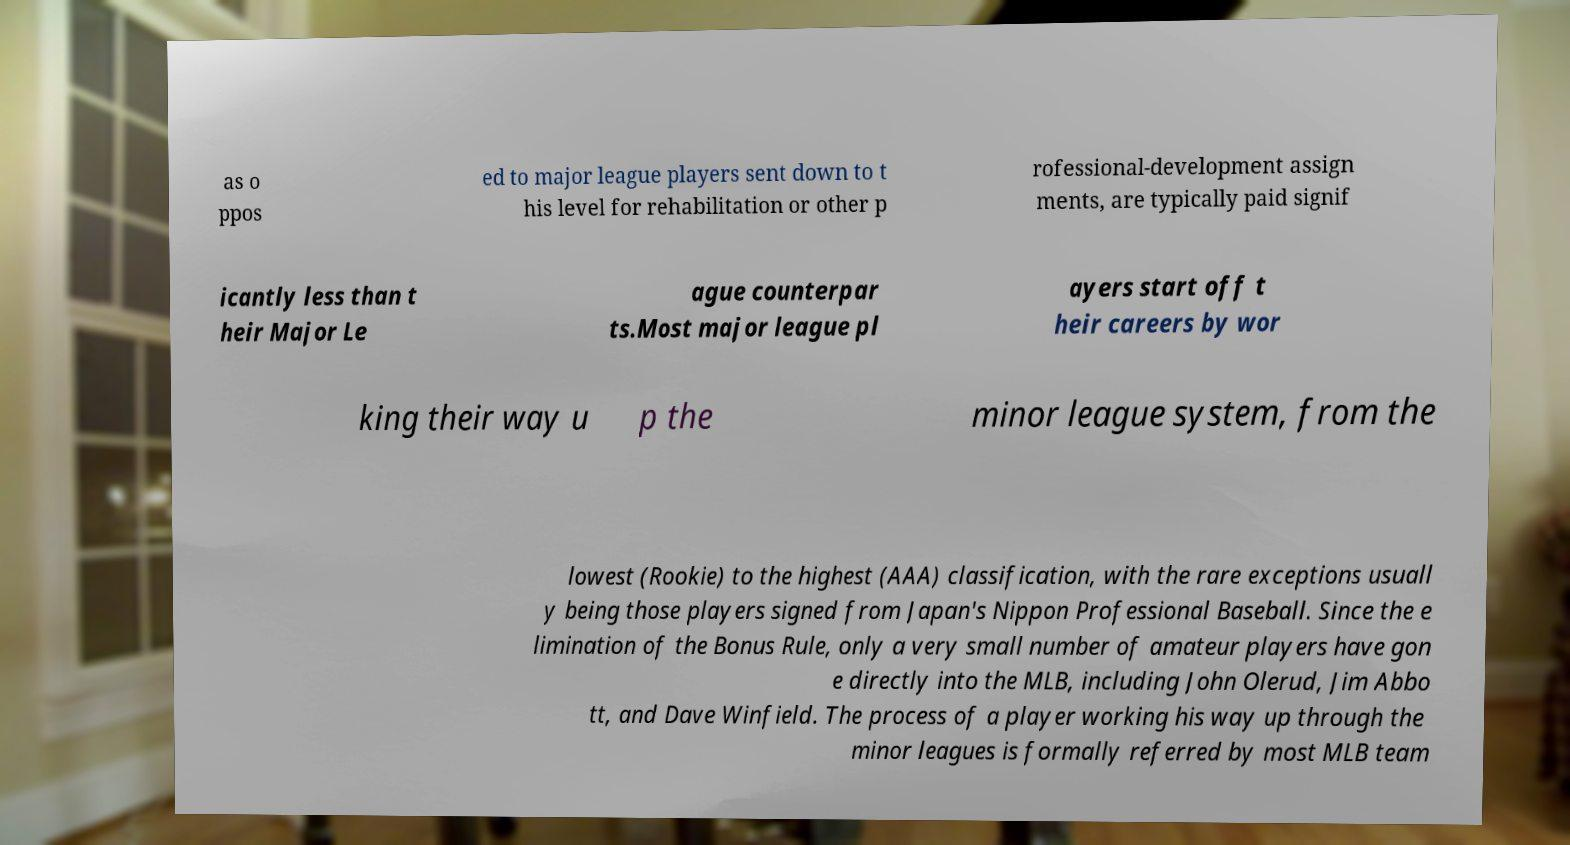Could you assist in decoding the text presented in this image and type it out clearly? as o ppos ed to major league players sent down to t his level for rehabilitation or other p rofessional-development assign ments, are typically paid signif icantly less than t heir Major Le ague counterpar ts.Most major league pl ayers start off t heir careers by wor king their way u p the minor league system, from the lowest (Rookie) to the highest (AAA) classification, with the rare exceptions usuall y being those players signed from Japan's Nippon Professional Baseball. Since the e limination of the Bonus Rule, only a very small number of amateur players have gon e directly into the MLB, including John Olerud, Jim Abbo tt, and Dave Winfield. The process of a player working his way up through the minor leagues is formally referred by most MLB team 